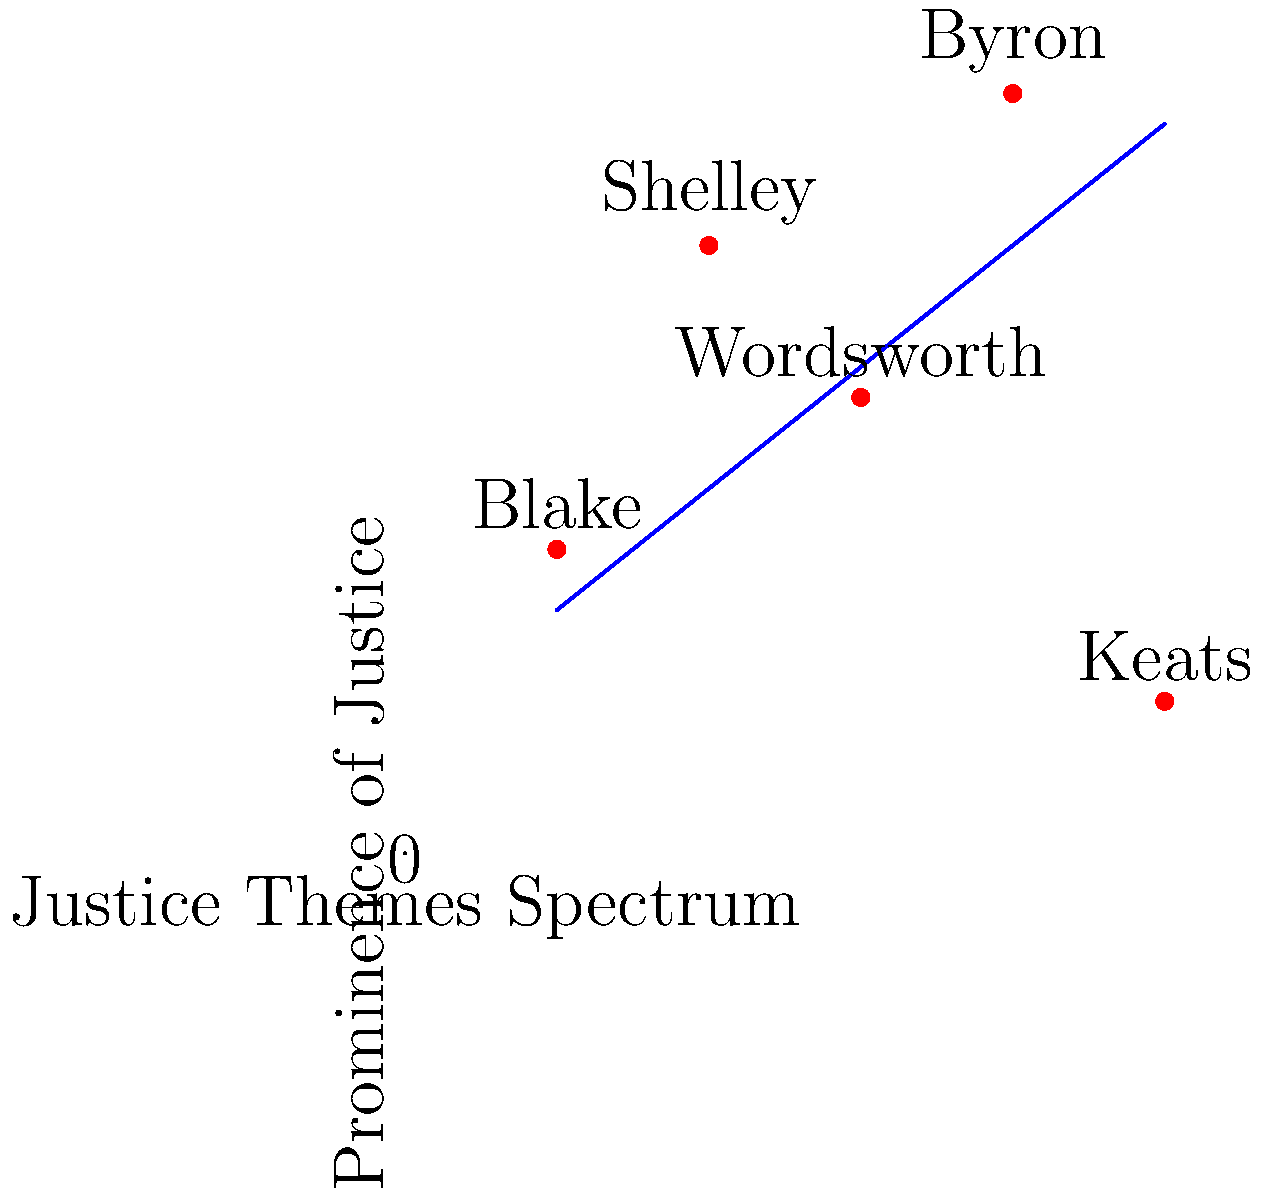Based on the graph representing the alignment of different Romantic poets' works on a spectrum of justice themes, which poet's work appears to deviate most significantly from the general trend shown by the blue line? To answer this question, we need to follow these steps:

1. Understand the graph:
   - The x-axis represents the "Justice Themes Spectrum"
   - The y-axis represents the "Prominence of Justice" in the poets' works
   - Each poet is represented by a red dot on the graph
   - The blue line represents the general trend

2. Observe the general trend:
   - The blue line shows a positive correlation between the justice themes spectrum and the prominence of justice in the works

3. Analyze each poet's position:
   - Blake: close to the trend line
   - Shelley: slightly above the trend line
   - Wordsworth: close to the trend line
   - Byron: slightly above the trend line
   - Keats: significantly below the trend line

4. Identify the outlier:
   - Keats' position is the furthest from the blue trend line, showing a much lower prominence of justice themes than expected based on his position on the spectrum

5. Conclude:
   - Keats' work deviates most significantly from the general trend
Answer: Keats 